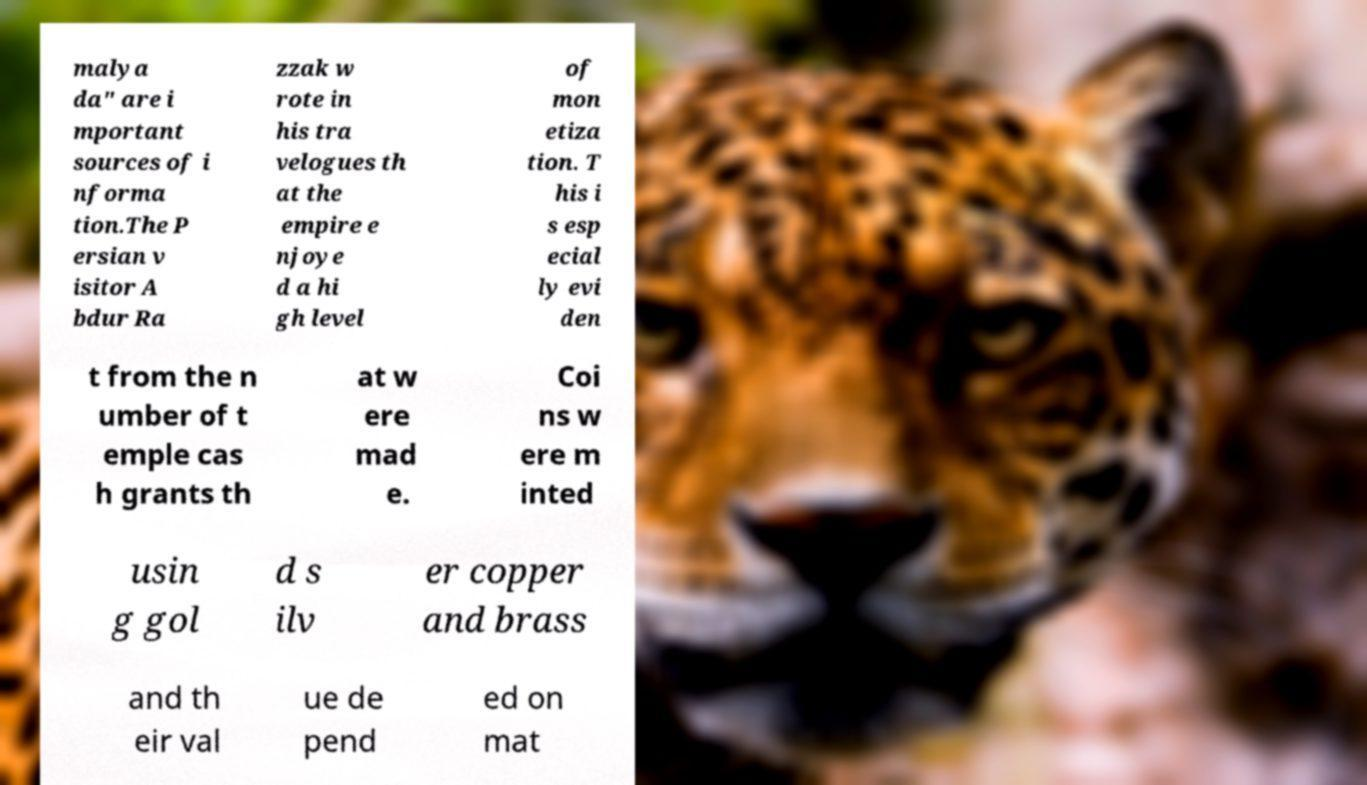Please identify and transcribe the text found in this image. malya da" are i mportant sources of i nforma tion.The P ersian v isitor A bdur Ra zzak w rote in his tra velogues th at the empire e njoye d a hi gh level of mon etiza tion. T his i s esp ecial ly evi den t from the n umber of t emple cas h grants th at w ere mad e. Coi ns w ere m inted usin g gol d s ilv er copper and brass and th eir val ue de pend ed on mat 